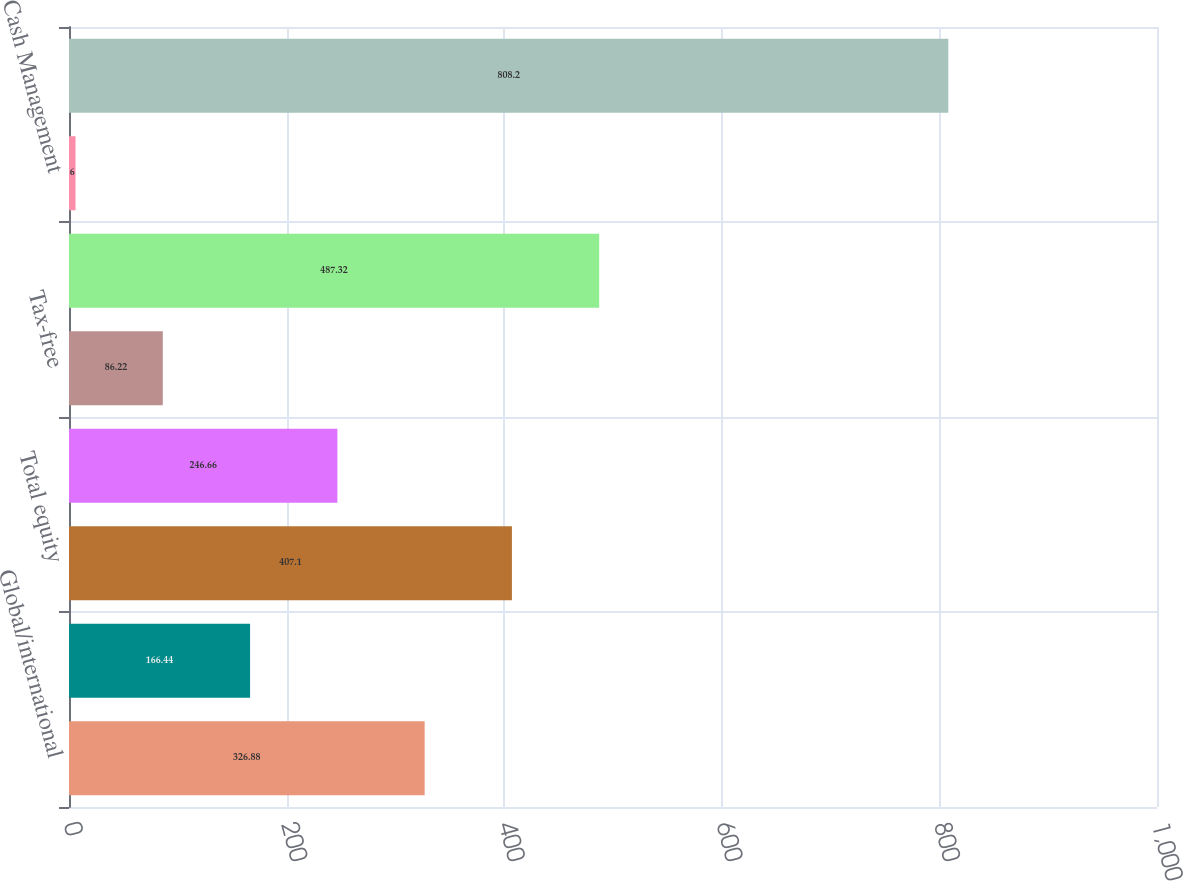Convert chart. <chart><loc_0><loc_0><loc_500><loc_500><bar_chart><fcel>Global/international<fcel>United States<fcel>Total equity<fcel>Hybrid<fcel>Tax-free<fcel>Total fixed-income<fcel>Cash Management<fcel>Total<nl><fcel>326.88<fcel>166.44<fcel>407.1<fcel>246.66<fcel>86.22<fcel>487.32<fcel>6<fcel>808.2<nl></chart> 